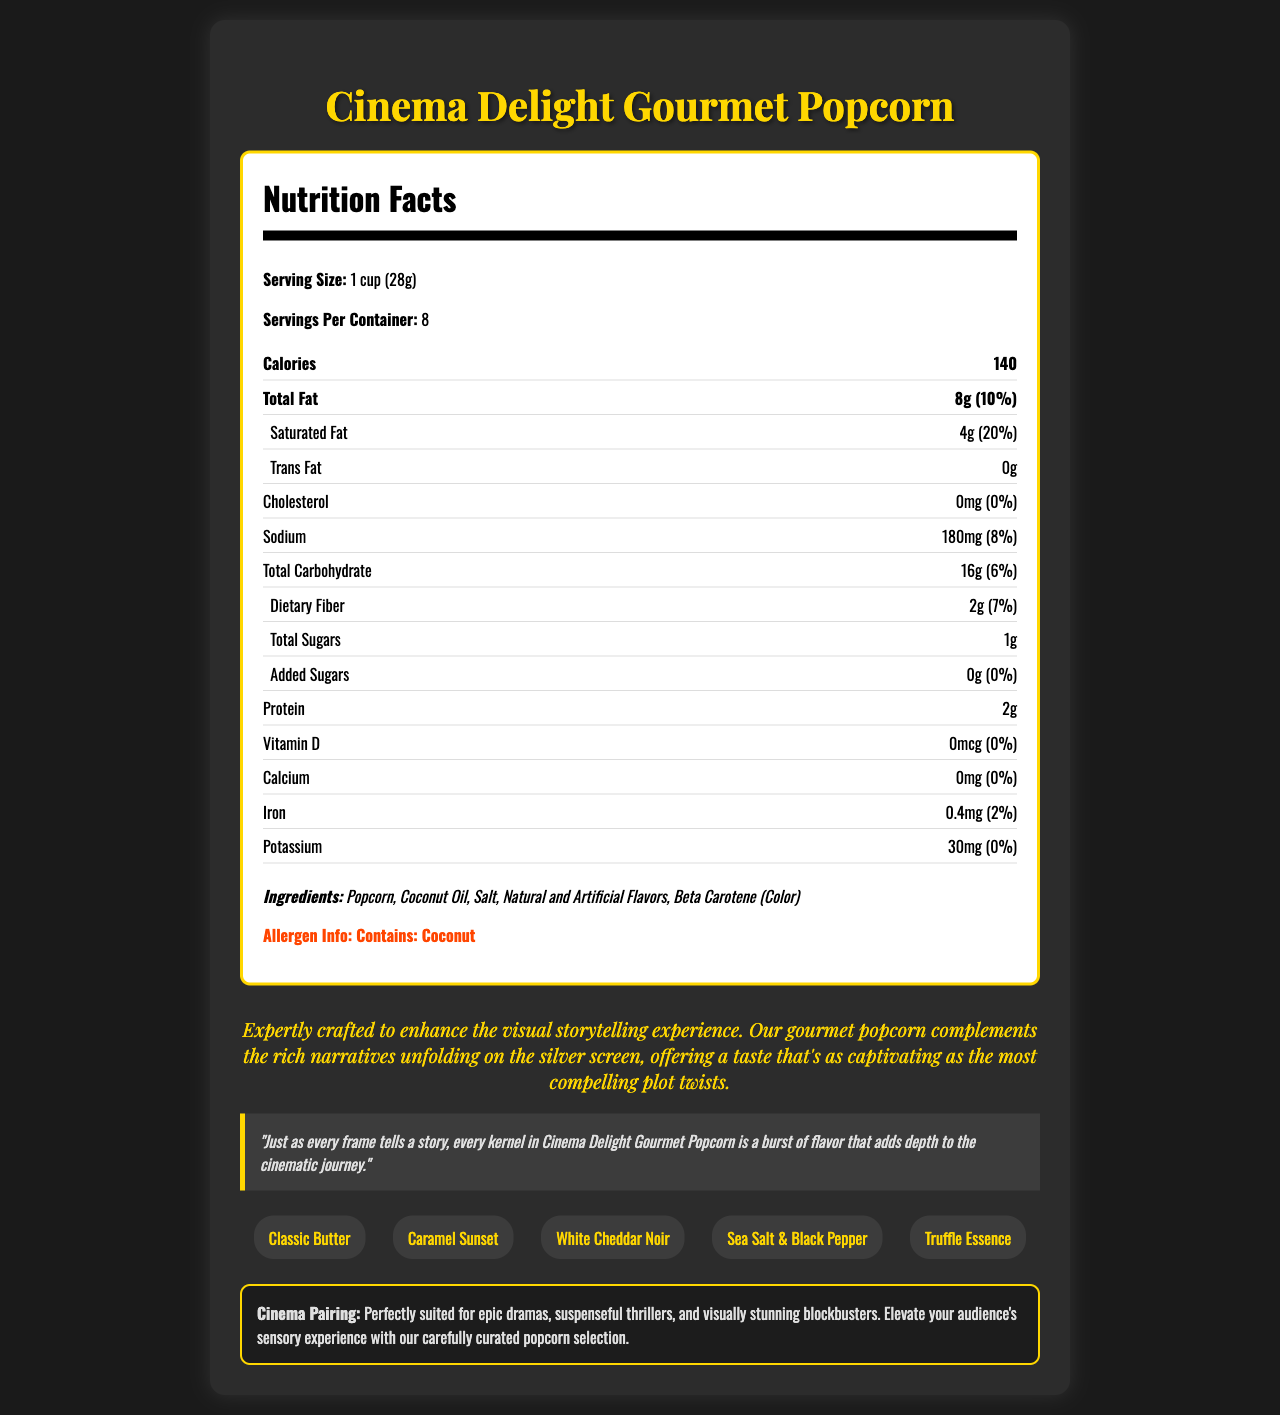what is the serving size of Cinema Delight Gourmet Popcorn? The serving size is clearly mentioned in the document under the "Serving Size" section as "1 cup (28g)".
Answer: 1 cup (28g) how many calories are there per serving? The document specifies that each serving contains 140 calories in the "Calories" section.
Answer: 140 calories what allergens are contained in the Cinema Delight Gourmet Popcorn? The allergen information is explicitly stated in the document as "Contains: Coconut".
Answer: Coconut how much sodium is in one serving of the popcorn? The sodium content per serving is listed in the "Sodium" section as "180mg (8% daily value)".
Answer: 180mg what are the ingredients listed for the popcorn? The ingredients are listed in the "Ingredients" section of the document.
Answer: Popcorn, Coconut Oil, Salt, Natural and Artificial Flavors, Beta Carotene (Color) how much protein is in one serving of the popcorn? The protein content per serving is specified as "2g" in the "Protein" section.
Answer: 2g how many servings are there per container? A. 6 B. 8 C. 10 D. 12 The document states that there are "8 servings per container".
Answer: B. 8 what is the percentage of daily value for saturated fat in one serving? A. 10% B. 15% C. 20% D. 25% The document indicates that the percentage of daily value for saturated fat per serving is "20%" in the "Saturated Fat" section.
Answer: C. 20% is there any trans fat in the popcorn? The document clearly lists "Trans Fat: 0g" indicating no trans fat in the popcorn.
Answer: No summarize the main idea of the document. The document encompasses all nutritional information, ingredients, potential allergens, flavor choices, and a thematic connection between the product and cinematic experiences.
Answer: This document provides detailed nutrition facts for the Cinema Delight Gourmet Popcorn, including serving size, calories, fat, cholesterol, sodium, carbohydrates, proteins, vitamins, and minerals per serving. It also lists the ingredients, allergens, available flavor varieties, and how the popcorn complements different movie genres. Additionally, it includes a quote from a director highlighting the thematic and gustatory allure of the popcorn. how much vitamin D is in one serving? The vitamin D content per serving is listed as "0mcg" in the "Vitamin D" section.
Answer: 0mcg does the popcorn contain any added sugars? The "Added Sugars" section states "0g (0% daily value)", indicating no added sugars.
Answer: No what flavors are available for Cinema Delight Gourmet Popcorn? The document lists the available flavor varieties in the "Flavor Varieties" section: "Classic Butter, Caramel Sunset, White Cheddar Noir, Sea Salt & Black Pepper, Truffle Essence".
Answer: Classic Butter, Caramel Sunset, White Cheddar Noir, Sea Salt & Black Pepper, Truffle Essence what is the total carbohydrate content in one serving? The total carbohydrate content per serving is "16g (6% daily value)" mentioned in the "Total Carbohydrate" section.
Answer: 16g what kind of movies does the popcorn pair well with according to the cinema pairing recommendation? The "Cinema Pairing" section describes that the popcorn is recommended for "epic dramas, suspenseful thrillers, and visually stunning blockbusters".
Answer: Epic dramas, suspenseful thrillers, and visually stunning blockbusters what is the shelf life of the popcorn? The document does not provide any information regarding the shelf life of the popcorn, so it cannot be determined from the visual information provided.
Answer: Cannot be determined 